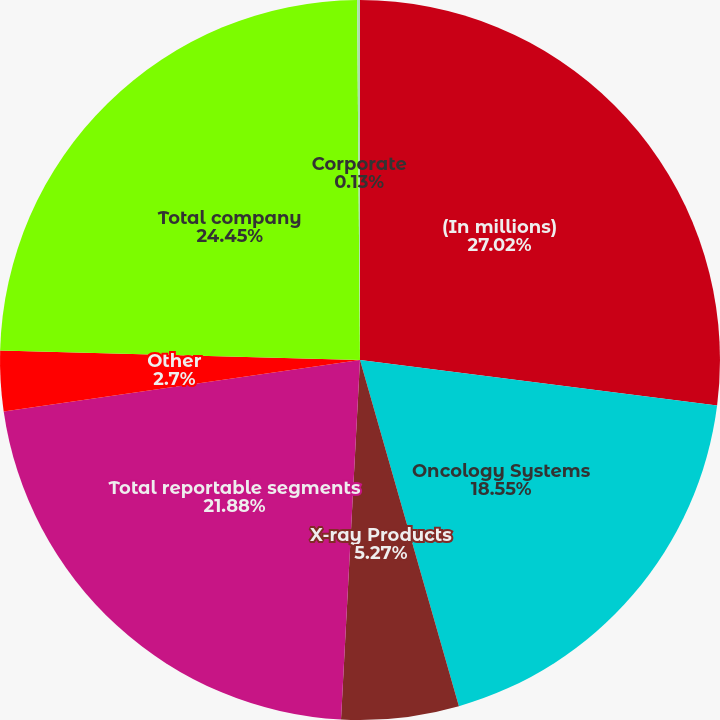Convert chart to OTSL. <chart><loc_0><loc_0><loc_500><loc_500><pie_chart><fcel>(In millions)<fcel>Oncology Systems<fcel>X-ray Products<fcel>Total reportable segments<fcel>Other<fcel>Total company<fcel>Corporate<nl><fcel>27.02%<fcel>18.55%<fcel>5.27%<fcel>21.88%<fcel>2.7%<fcel>24.45%<fcel>0.13%<nl></chart> 